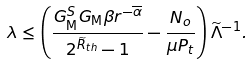Convert formula to latex. <formula><loc_0><loc_0><loc_500><loc_500>\lambda \leq \left ( \frac { { G _ { \text {M} } ^ { S } G _ { \text {M} } \beta } r ^ { - { \overline { \alpha } } } } { 2 ^ { \widetilde { R } _ { t h } } - 1 } - \frac { N _ { o } } { \mu P _ { t } } \right ) { \widetilde { \Lambda } } ^ { - 1 } .</formula> 